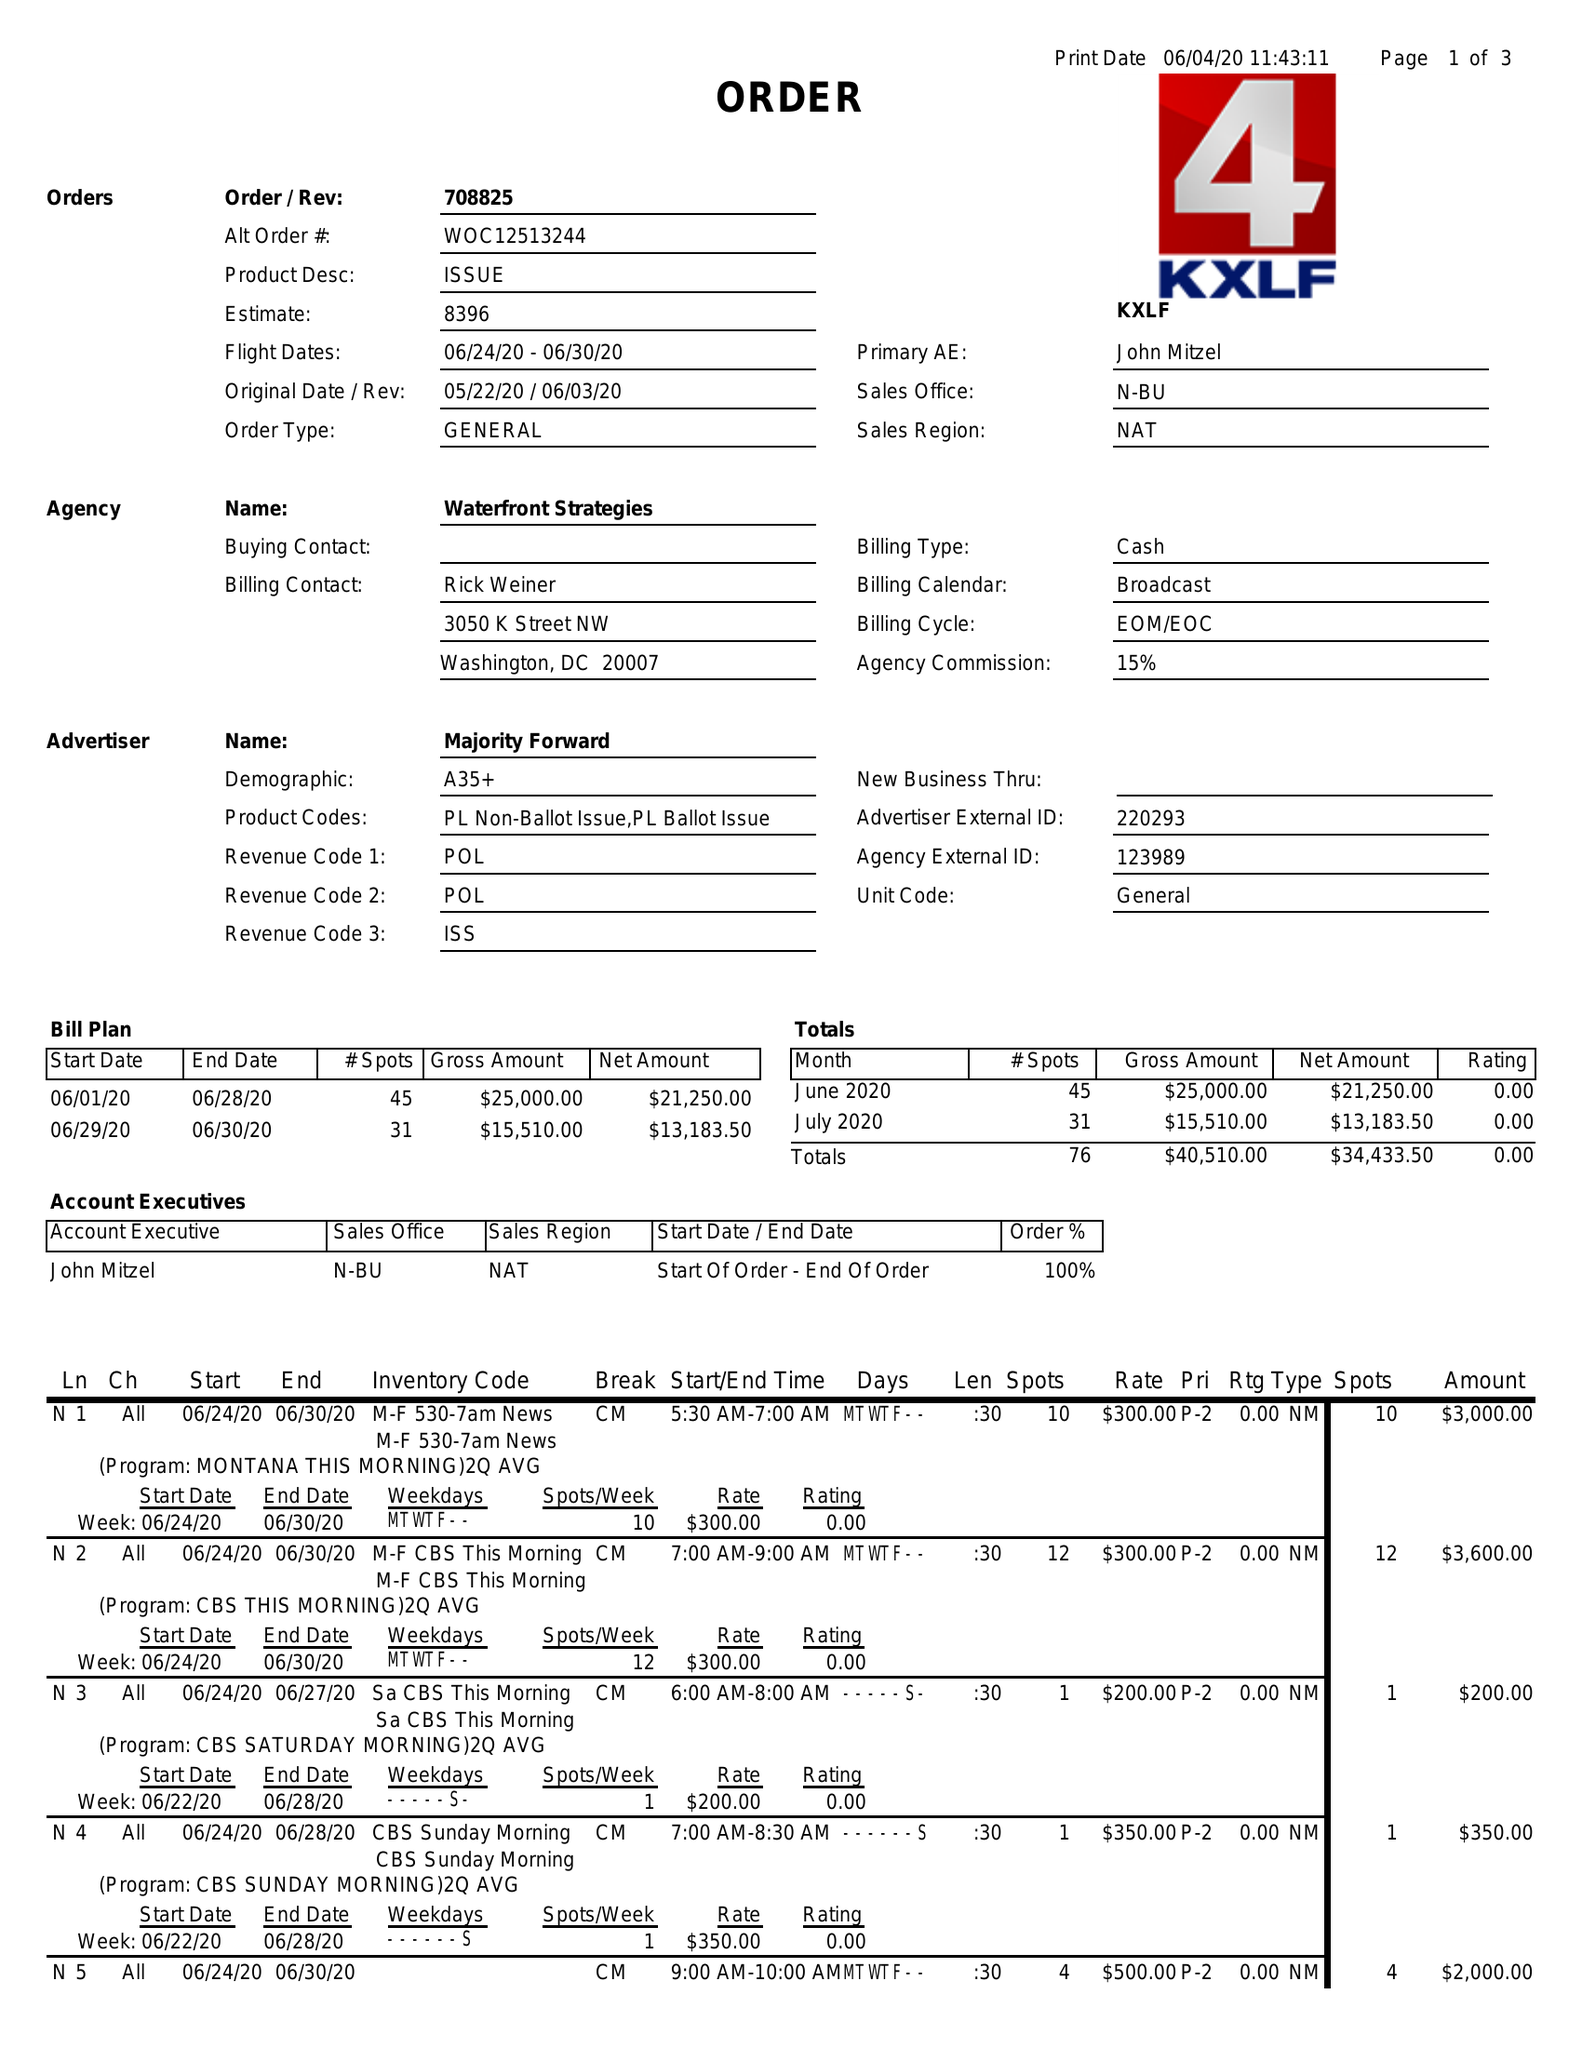What is the value for the flight_to?
Answer the question using a single word or phrase. 06/30/20 